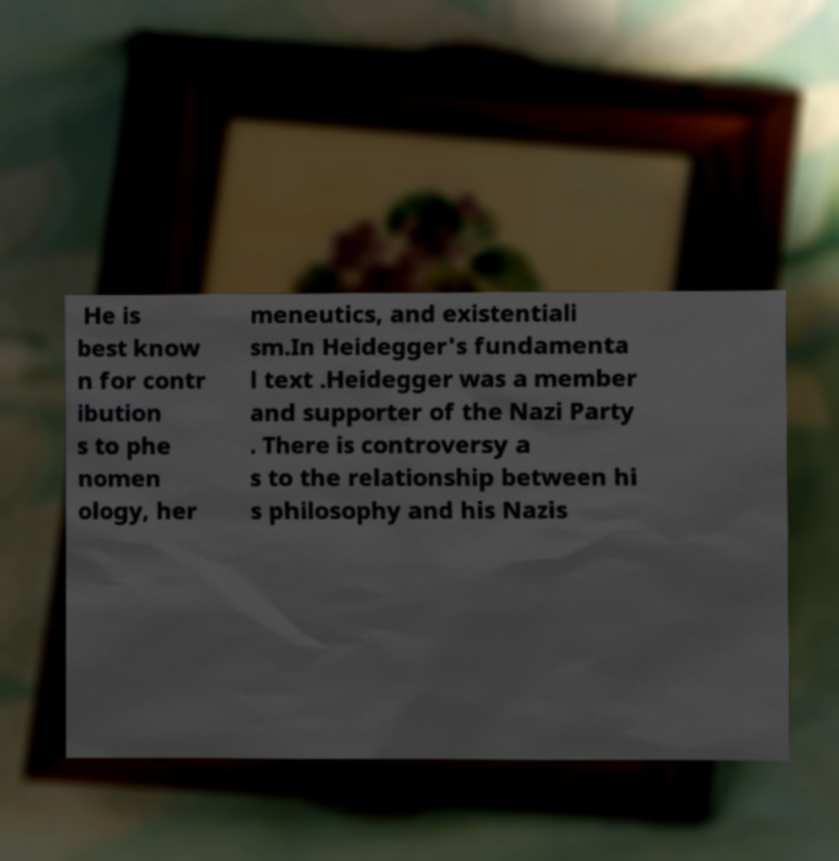Could you extract and type out the text from this image? He is best know n for contr ibution s to phe nomen ology, her meneutics, and existentiali sm.In Heidegger's fundamenta l text .Heidegger was a member and supporter of the Nazi Party . There is controversy a s to the relationship between hi s philosophy and his Nazis 